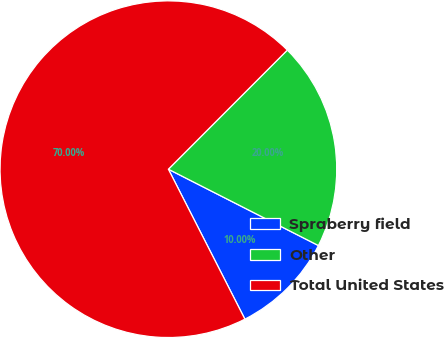<chart> <loc_0><loc_0><loc_500><loc_500><pie_chart><fcel>Spraberry field<fcel>Other<fcel>Total United States<nl><fcel>10.0%<fcel>20.0%<fcel>70.0%<nl></chart> 